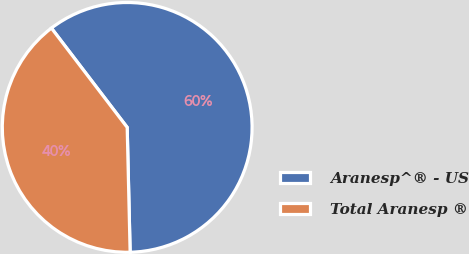Convert chart. <chart><loc_0><loc_0><loc_500><loc_500><pie_chart><fcel>Aranesp^® - US<fcel>Total Aranesp ®<nl><fcel>60.0%<fcel>40.0%<nl></chart> 